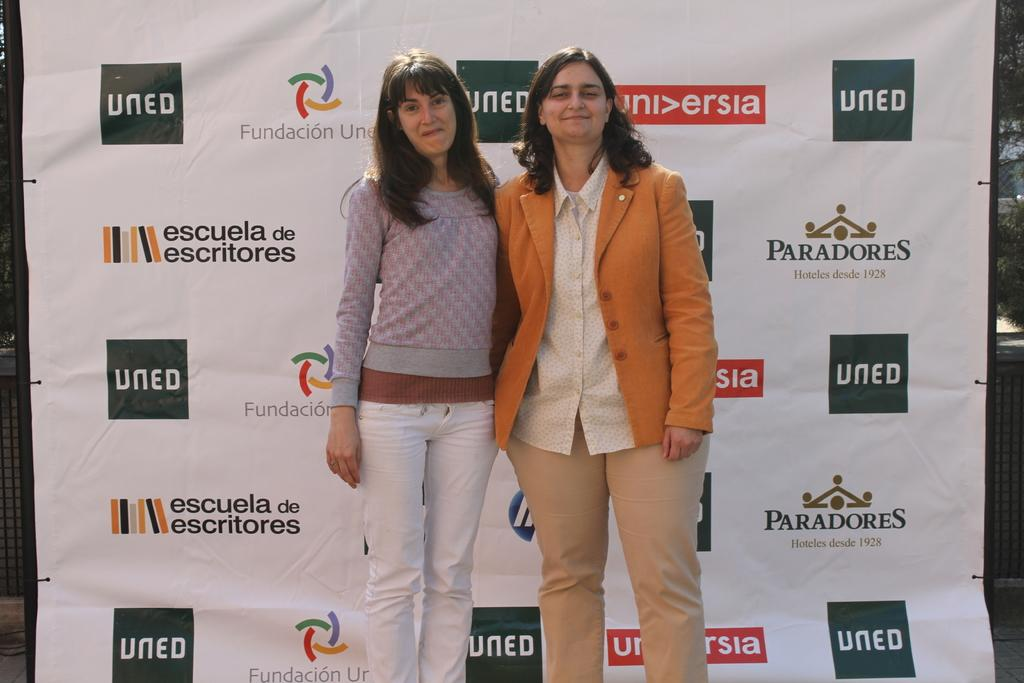How many people are in the image? There are two women standing in the image. What are the women wearing? The women are wearing clothes. What expression do the women have? The women are smiling. What can be seen in the background of the image? There is a poster visible in the background. What is written on the poster? There is text on the poster. What type of pail can be seen in the image? There is no pail present in the image. What season is depicted in the image? The provided facts do not mention any season or time of year. 